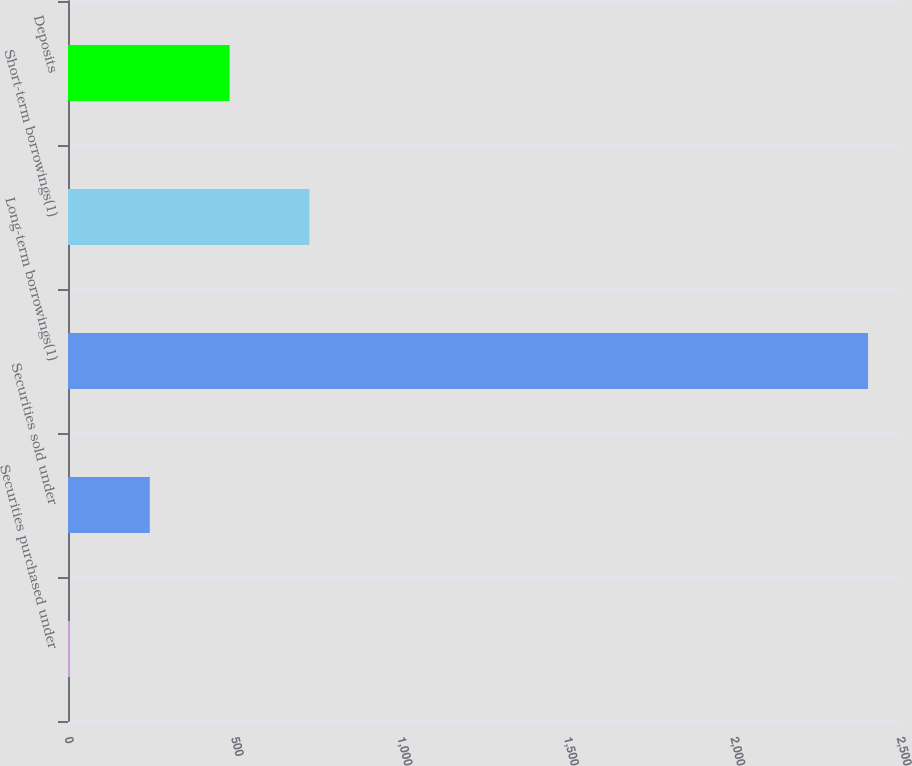Convert chart to OTSL. <chart><loc_0><loc_0><loc_500><loc_500><bar_chart><fcel>Securities purchased under<fcel>Securities sold under<fcel>Long-term borrowings(1)<fcel>Short-term borrowings(1)<fcel>Deposits<nl><fcel>6<fcel>245.8<fcel>2404<fcel>725.4<fcel>485.6<nl></chart> 